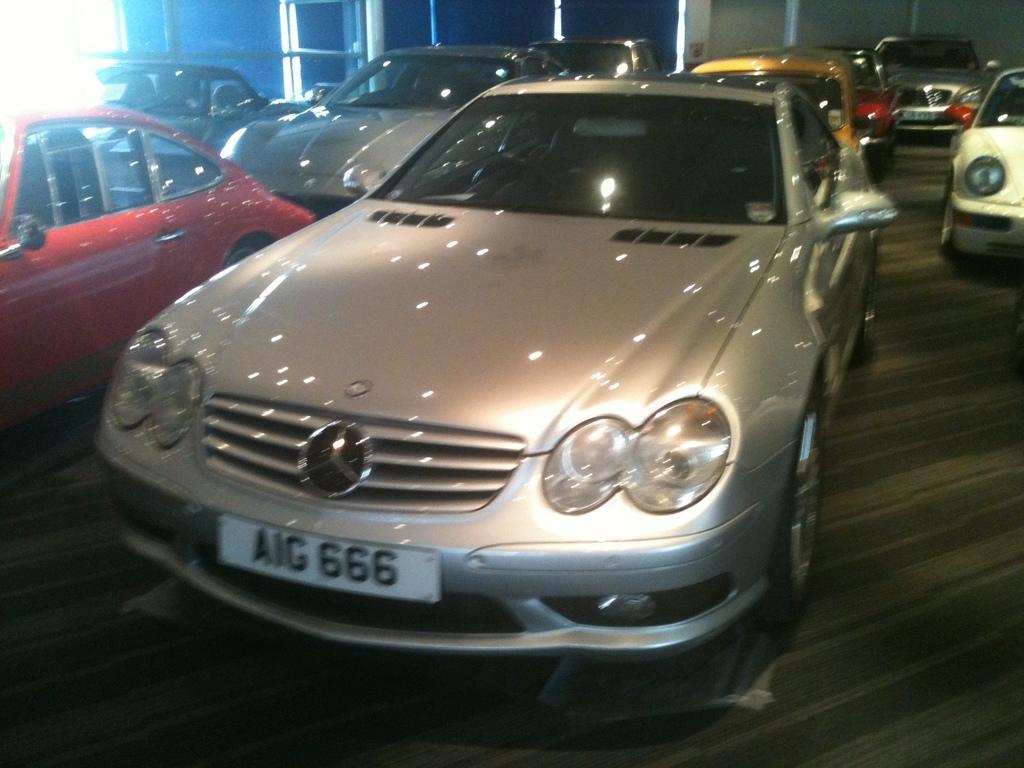Could you give a brief overview of what you see in this image? Here we can see cars on the floor. In the background we can see poles and wall. 